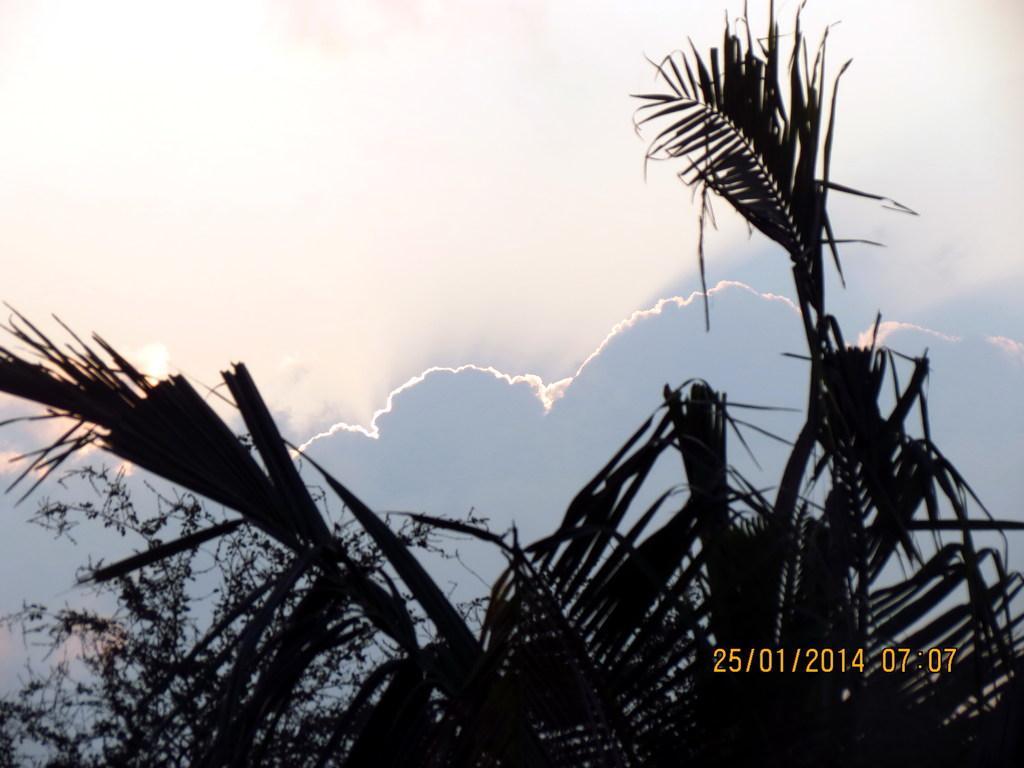In one or two sentences, can you explain what this image depicts? There are trees. In the background there is sky with clouds. On the right corner there is date and time. 